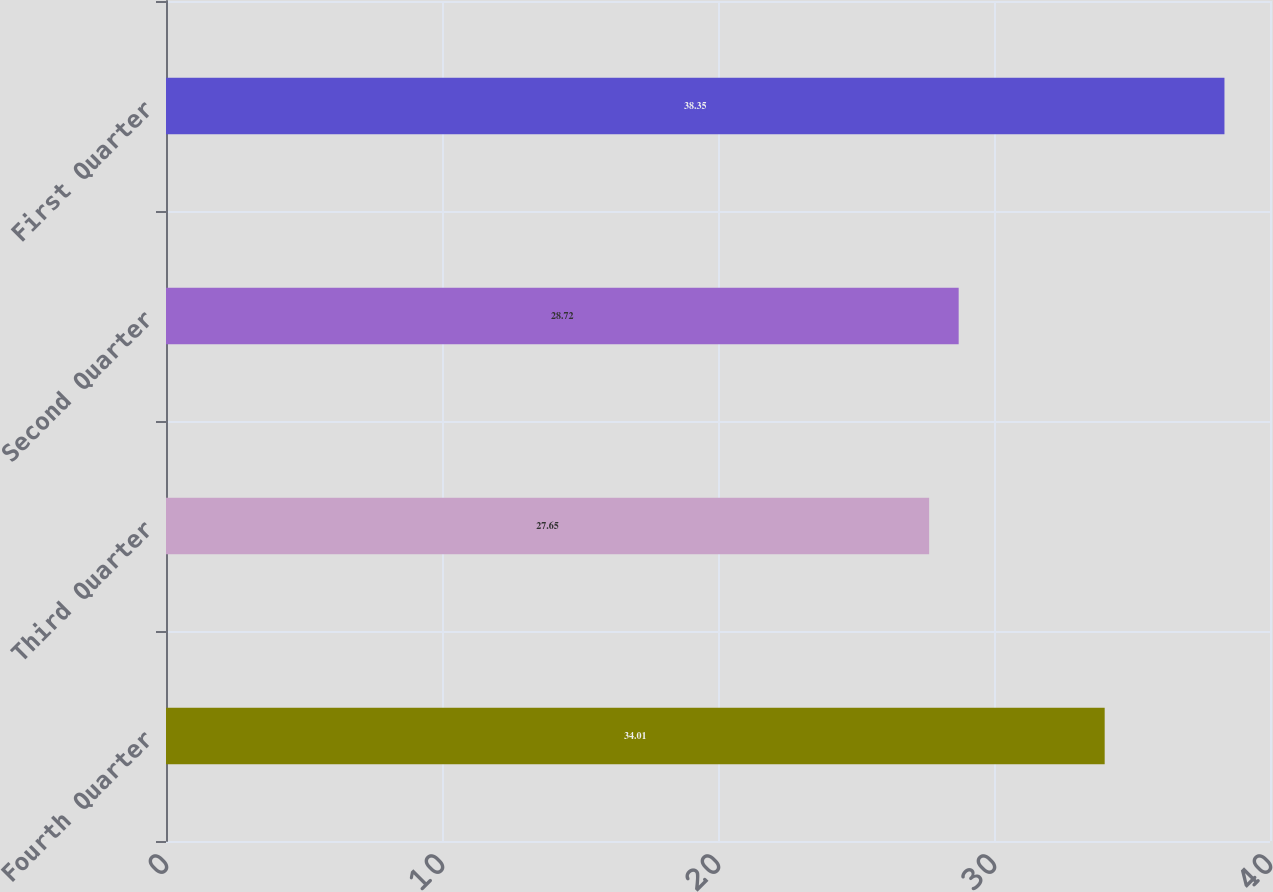<chart> <loc_0><loc_0><loc_500><loc_500><bar_chart><fcel>Fourth Quarter<fcel>Third Quarter<fcel>Second Quarter<fcel>First Quarter<nl><fcel>34.01<fcel>27.65<fcel>28.72<fcel>38.35<nl></chart> 